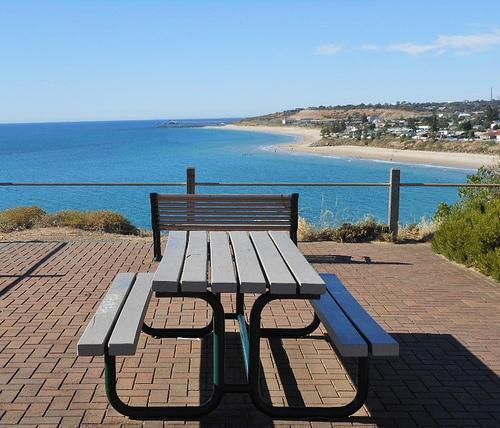How many picnic benches are in the photo?
Give a very brief answer. 1. How many shadows are in the photo?
Give a very brief answer. 3. How many fence posts are seen in the photo?
Give a very brief answer. 2. How many seats does the picnic bench have?
Give a very brief answer. 2. 